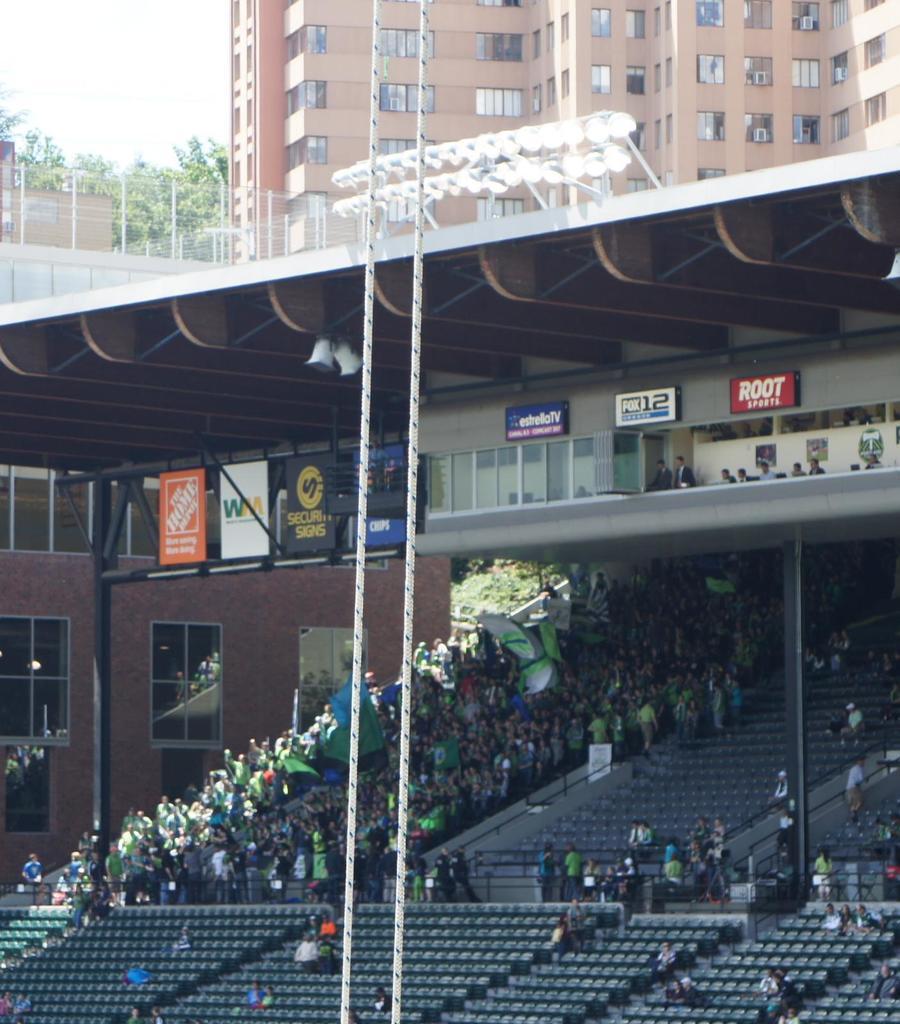Please provide a concise description of this image. The picture is clicked in a stadium where we observe people sitting on the chairs and there i a building in the background. 